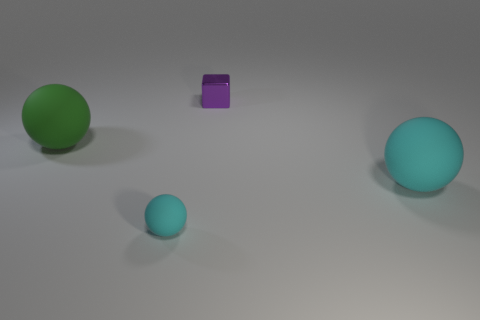Are there any small things that are left of the object that is to the left of the tiny sphere?
Offer a terse response. No. Are there fewer purple cubes behind the tiny cyan object than large cyan matte objects?
Ensure brevity in your answer.  No. Is the material of the big ball that is on the right side of the small block the same as the big green sphere?
Offer a terse response. Yes. The other big sphere that is the same material as the large green ball is what color?
Provide a short and direct response. Cyan. Is the number of tiny cyan balls that are in front of the green thing less than the number of tiny cyan balls that are to the left of the tiny purple metal thing?
Give a very brief answer. No. Is the color of the rubber object that is right of the purple block the same as the big sphere left of the tiny ball?
Make the answer very short. No. Is there a purple thing that has the same material as the big cyan sphere?
Your response must be concise. No. There is a cyan matte thing to the right of the cyan rubber thing left of the purple block; what size is it?
Offer a terse response. Large. Are there more red matte balls than green spheres?
Offer a very short reply. No. There is a object behind the green rubber ball; is its size the same as the small cyan object?
Give a very brief answer. Yes. 